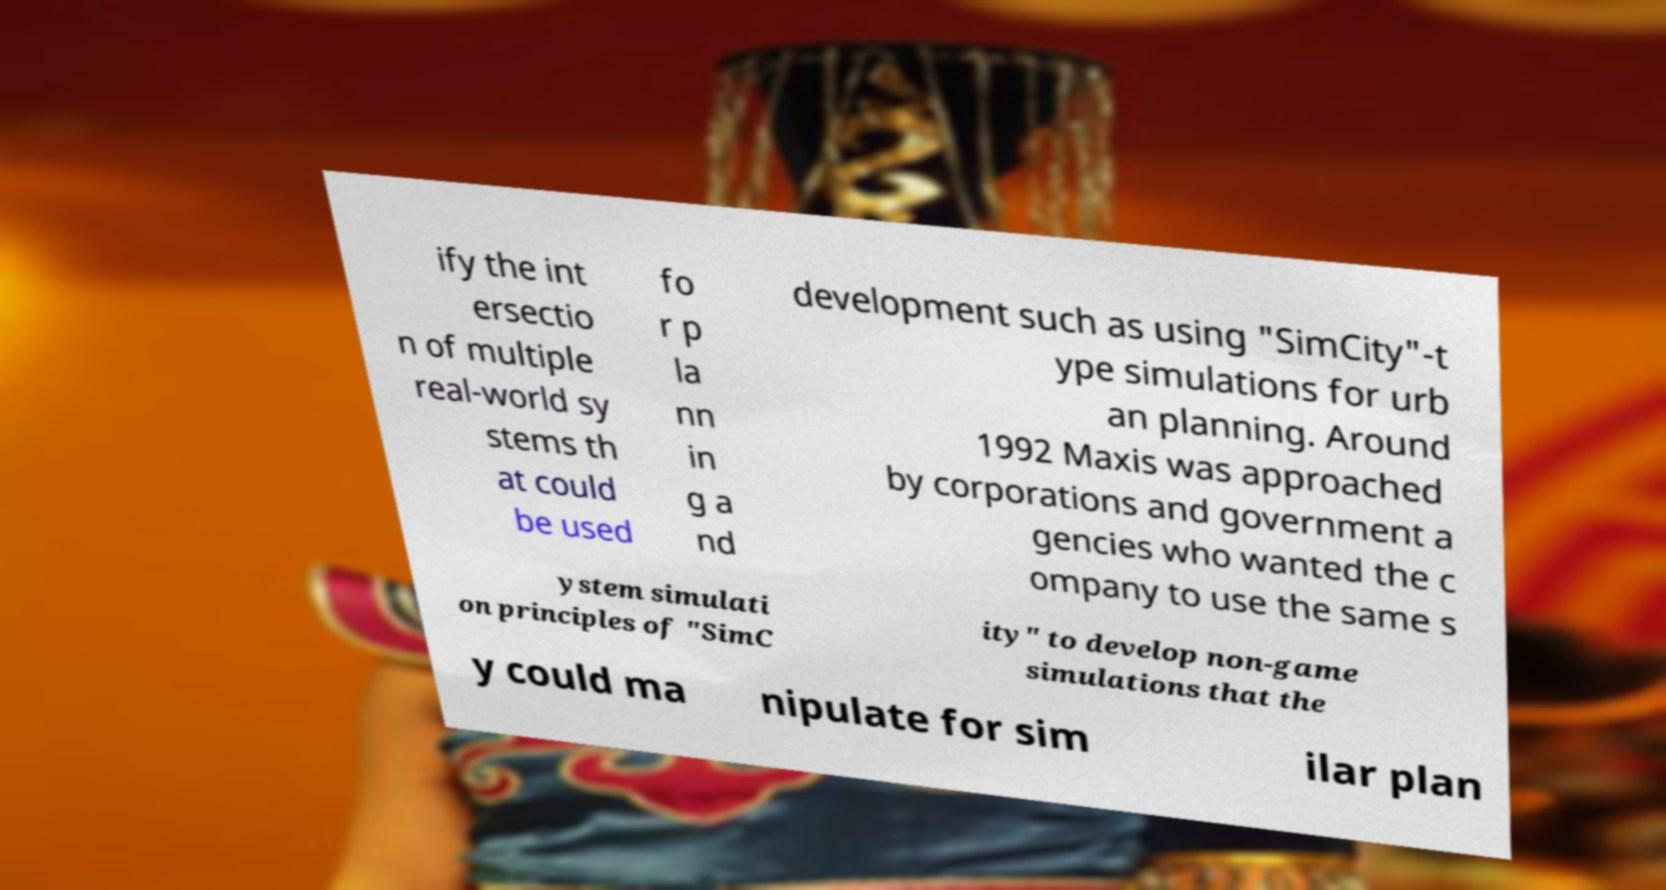Please identify and transcribe the text found in this image. ify the int ersectio n of multiple real-world sy stems th at could be used fo r p la nn in g a nd development such as using "SimCity"-t ype simulations for urb an planning. Around 1992 Maxis was approached by corporations and government a gencies who wanted the c ompany to use the same s ystem simulati on principles of "SimC ity" to develop non-game simulations that the y could ma nipulate for sim ilar plan 